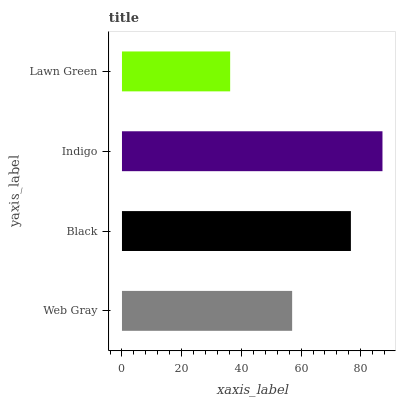Is Lawn Green the minimum?
Answer yes or no. Yes. Is Indigo the maximum?
Answer yes or no. Yes. Is Black the minimum?
Answer yes or no. No. Is Black the maximum?
Answer yes or no. No. Is Black greater than Web Gray?
Answer yes or no. Yes. Is Web Gray less than Black?
Answer yes or no. Yes. Is Web Gray greater than Black?
Answer yes or no. No. Is Black less than Web Gray?
Answer yes or no. No. Is Black the high median?
Answer yes or no. Yes. Is Web Gray the low median?
Answer yes or no. Yes. Is Web Gray the high median?
Answer yes or no. No. Is Lawn Green the low median?
Answer yes or no. No. 